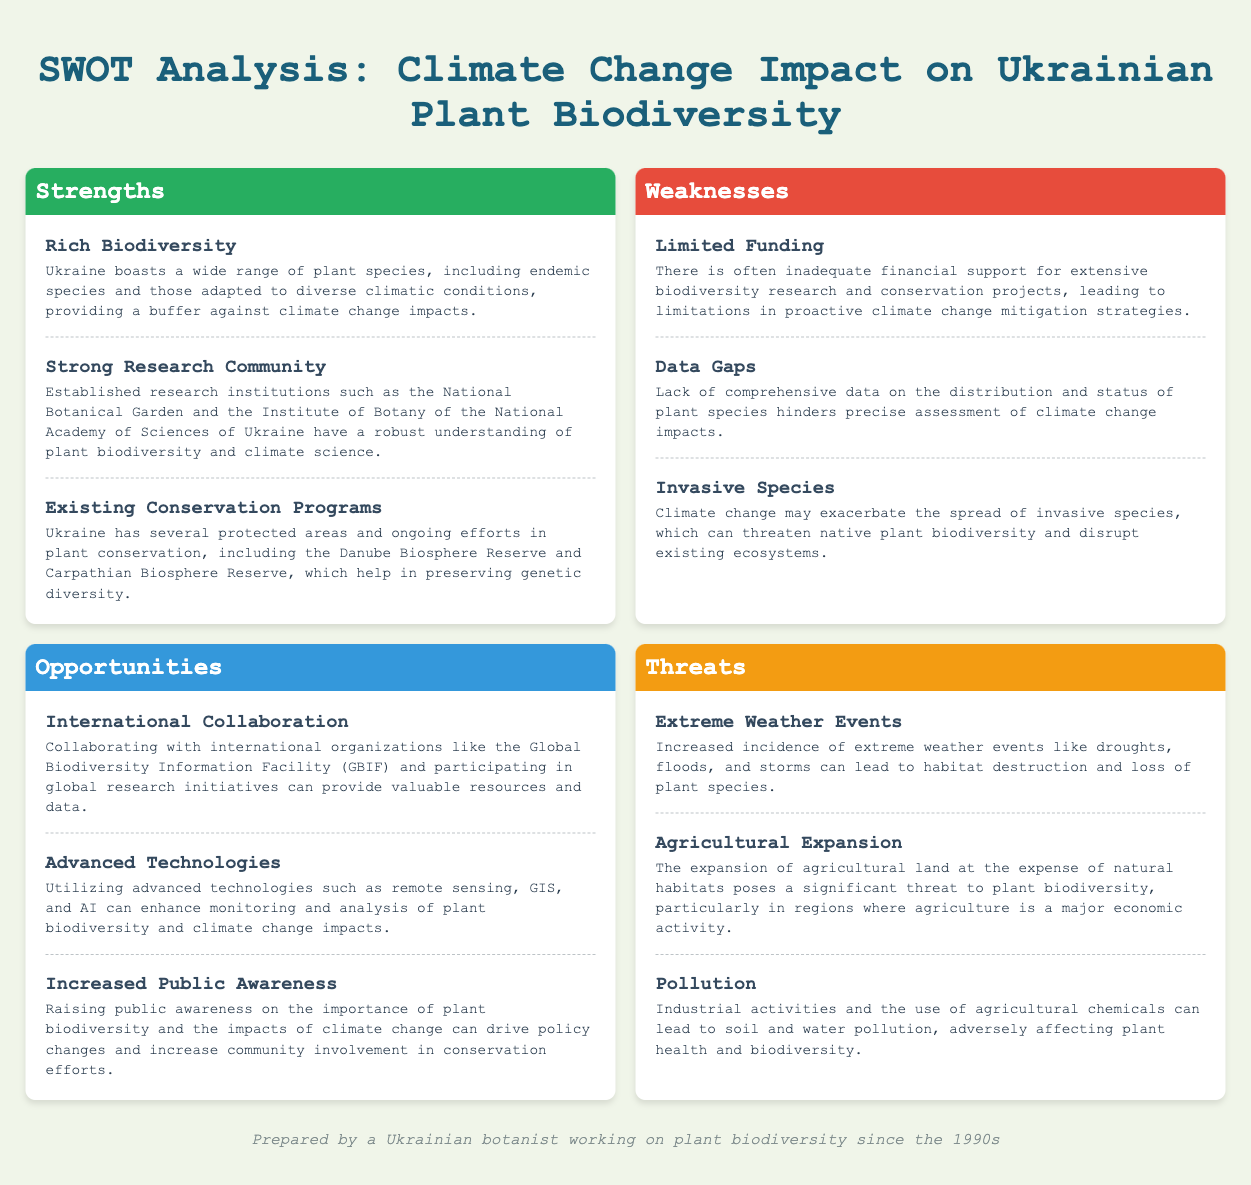What is one of Ukraine's strengths in plant biodiversity? Strengths highlight positive aspects, and one of the strengths mentioned is "Rich Biodiversity."
Answer: Rich Biodiversity What type of programs does Ukraine already have for plant conservation? The document mentions "Existing Conservation Programs" as a strength, indicating ongoing efforts for plant conservation.
Answer: Existing Conservation Programs What is a significant weakness related to funding? The document discusses "Limited Funding" as a weakness, showing the financial shortcomings faced in biodiversity projects.
Answer: Limited Funding Name one opportunity for improving biodiversity research mentioned in the document. The document lists "International Collaboration" as an opportunity for enhancing resources and data through partnerships.
Answer: International Collaboration What environmental challenge is considered a threat to plant biodiversity? The document states "Extreme Weather Events" as a threat, indicating the impact of climate factors on plant ecosystems.
Answer: Extreme Weather Events What advanced technology can be utilized to monitor biodiversity? The document suggests "Advanced Technologies" like GIS and AI for improving monitoring and analysis of biodiversity impacts.
Answer: Advanced Technologies How does the document classify the impact of invasive species? The weaknesses section includes "Invasive Species" as a concern for native biodiversity, highlighting risks posed by climate change.
Answer: Invasive Species What can increased public awareness drive according to the document? The document states that public awareness can lead to "policy changes" and community involvement in conservation efforts.
Answer: Policy changes Which area in Ukraine is mentioned specifically for plant conservation? "Carpathian Biosphere Reserve" is listed in the strengths section as part of ongoing conservation efforts.
Answer: Carpathian Biosphere Reserve 